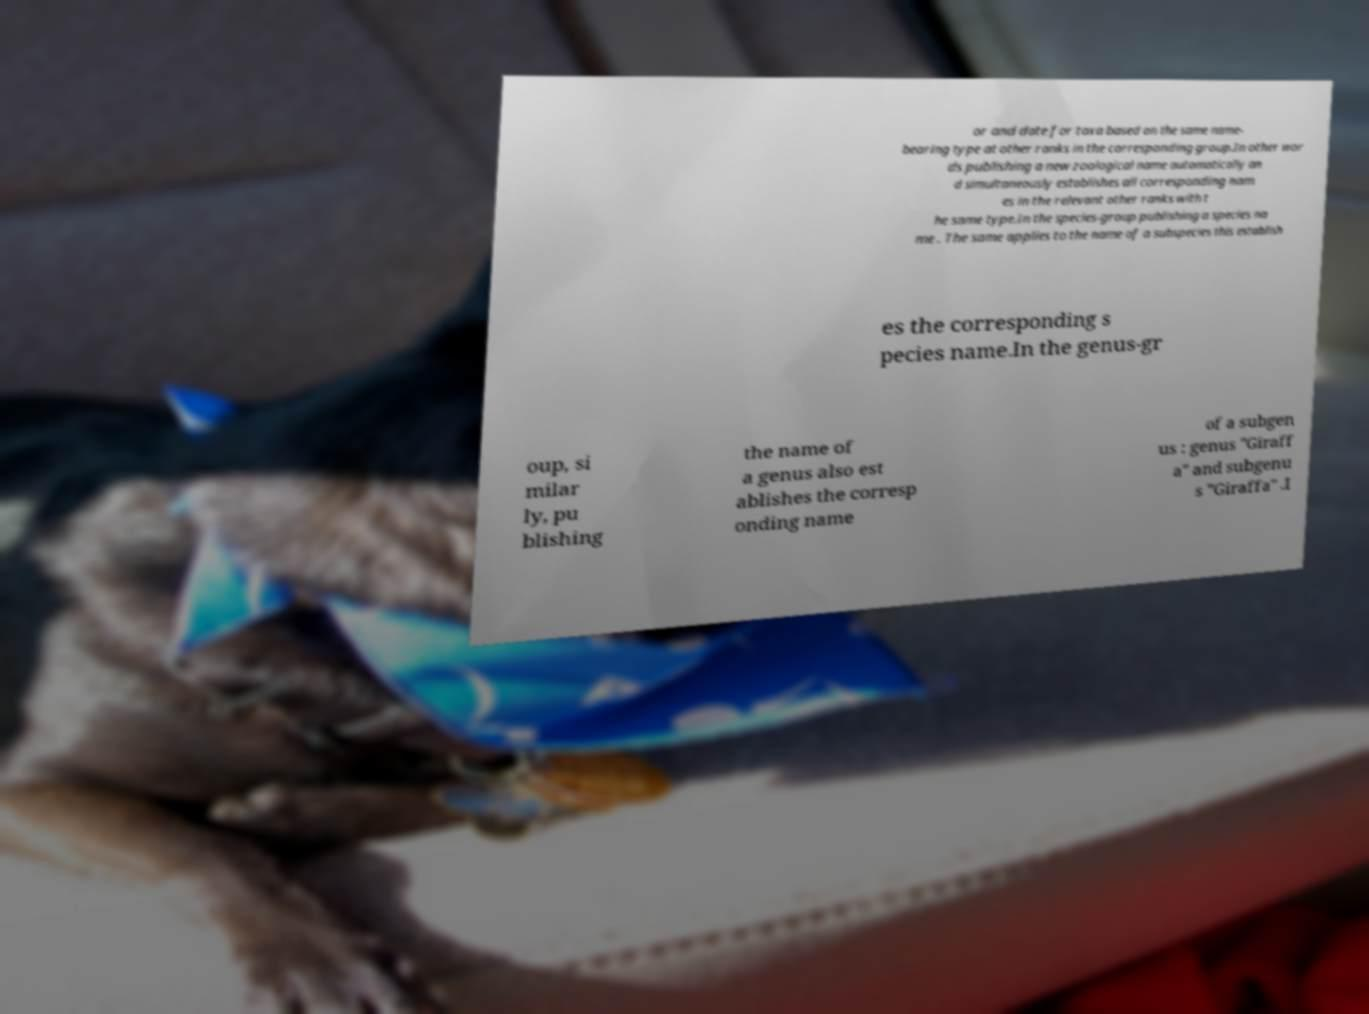Could you assist in decoding the text presented in this image and type it out clearly? or and date for taxa based on the same name- bearing type at other ranks in the corresponding group.In other wor ds publishing a new zoological name automatically an d simultaneously establishes all corresponding nam es in the relevant other ranks with t he same type.In the species-group publishing a species na me . The same applies to the name of a subspecies this establish es the corresponding s pecies name.In the genus-gr oup, si milar ly, pu blishing the name of a genus also est ablishes the corresp onding name of a subgen us : genus "Giraff a" and subgenu s "Giraffa" .I 